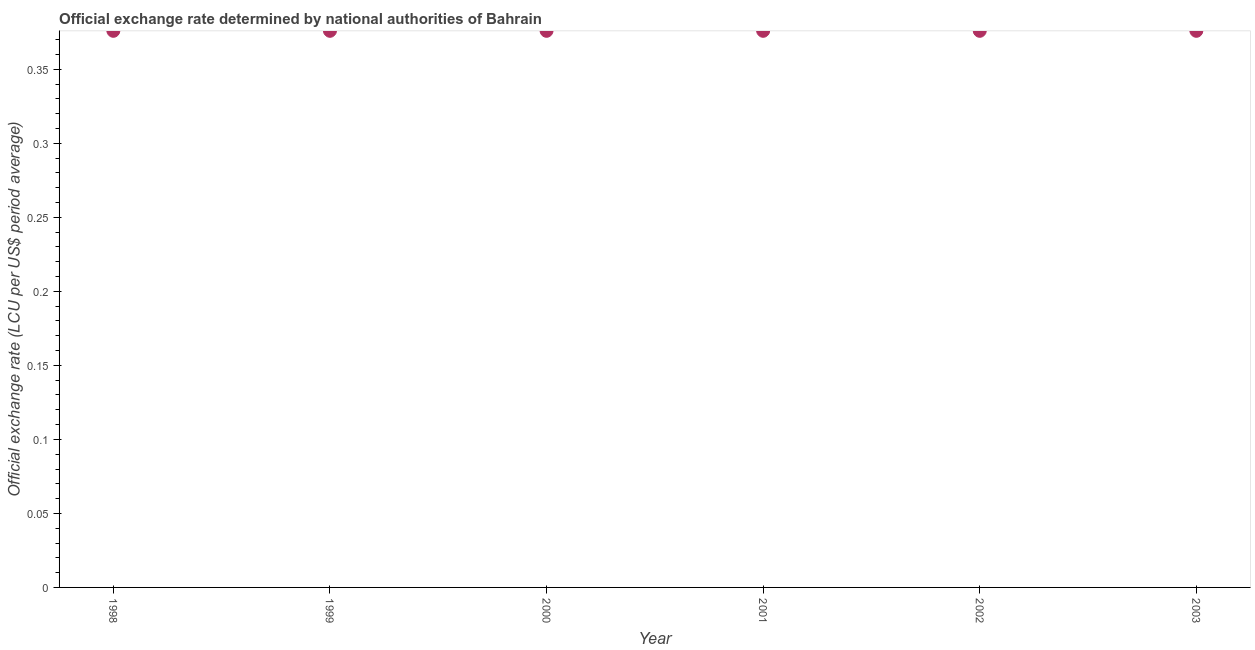What is the official exchange rate in 2002?
Keep it short and to the point. 0.38. Across all years, what is the maximum official exchange rate?
Give a very brief answer. 0.38. Across all years, what is the minimum official exchange rate?
Offer a terse response. 0.38. In which year was the official exchange rate maximum?
Provide a short and direct response. 2000. What is the sum of the official exchange rate?
Your answer should be very brief. 2.26. What is the difference between the official exchange rate in 2000 and 2002?
Give a very brief answer. 0. What is the average official exchange rate per year?
Offer a very short reply. 0.38. What is the median official exchange rate?
Keep it short and to the point. 0.38. In how many years, is the official exchange rate greater than 0.12000000000000001 ?
Offer a terse response. 6. Do a majority of the years between 1999 and 2000 (inclusive) have official exchange rate greater than 0.26 ?
Offer a terse response. Yes. What is the ratio of the official exchange rate in 1999 to that in 2002?
Offer a very short reply. 1. Is the official exchange rate in 1999 less than that in 2003?
Give a very brief answer. Yes. Is the sum of the official exchange rate in 2000 and 2003 greater than the maximum official exchange rate across all years?
Provide a short and direct response. Yes. What is the difference between the highest and the lowest official exchange rate?
Your answer should be very brief. 3.7499999994139444e-8. How many years are there in the graph?
Ensure brevity in your answer.  6. Are the values on the major ticks of Y-axis written in scientific E-notation?
Provide a succinct answer. No. Does the graph contain any zero values?
Your answer should be compact. No. What is the title of the graph?
Provide a succinct answer. Official exchange rate determined by national authorities of Bahrain. What is the label or title of the Y-axis?
Ensure brevity in your answer.  Official exchange rate (LCU per US$ period average). What is the Official exchange rate (LCU per US$ period average) in 1998?
Ensure brevity in your answer.  0.38. What is the Official exchange rate (LCU per US$ period average) in 1999?
Your answer should be compact. 0.38. What is the Official exchange rate (LCU per US$ period average) in 2000?
Offer a very short reply. 0.38. What is the Official exchange rate (LCU per US$ period average) in 2001?
Offer a very short reply. 0.38. What is the Official exchange rate (LCU per US$ period average) in 2002?
Offer a very short reply. 0.38. What is the Official exchange rate (LCU per US$ period average) in 2003?
Provide a short and direct response. 0.38. What is the difference between the Official exchange rate (LCU per US$ period average) in 1998 and 2000?
Offer a terse response. -0. What is the difference between the Official exchange rate (LCU per US$ period average) in 1998 and 2001?
Make the answer very short. -0. What is the difference between the Official exchange rate (LCU per US$ period average) in 1999 and 2002?
Keep it short and to the point. -0. What is the difference between the Official exchange rate (LCU per US$ period average) in 1999 and 2003?
Your answer should be very brief. -0. What is the difference between the Official exchange rate (LCU per US$ period average) in 2000 and 2003?
Your response must be concise. 0. What is the difference between the Official exchange rate (LCU per US$ period average) in 2001 and 2003?
Your response must be concise. 0. What is the ratio of the Official exchange rate (LCU per US$ period average) in 1998 to that in 1999?
Your answer should be compact. 1. What is the ratio of the Official exchange rate (LCU per US$ period average) in 1999 to that in 2000?
Offer a terse response. 1. What is the ratio of the Official exchange rate (LCU per US$ period average) in 1999 to that in 2003?
Give a very brief answer. 1. What is the ratio of the Official exchange rate (LCU per US$ period average) in 2000 to that in 2003?
Give a very brief answer. 1. What is the ratio of the Official exchange rate (LCU per US$ period average) in 2001 to that in 2003?
Keep it short and to the point. 1. What is the ratio of the Official exchange rate (LCU per US$ period average) in 2002 to that in 2003?
Offer a terse response. 1. 